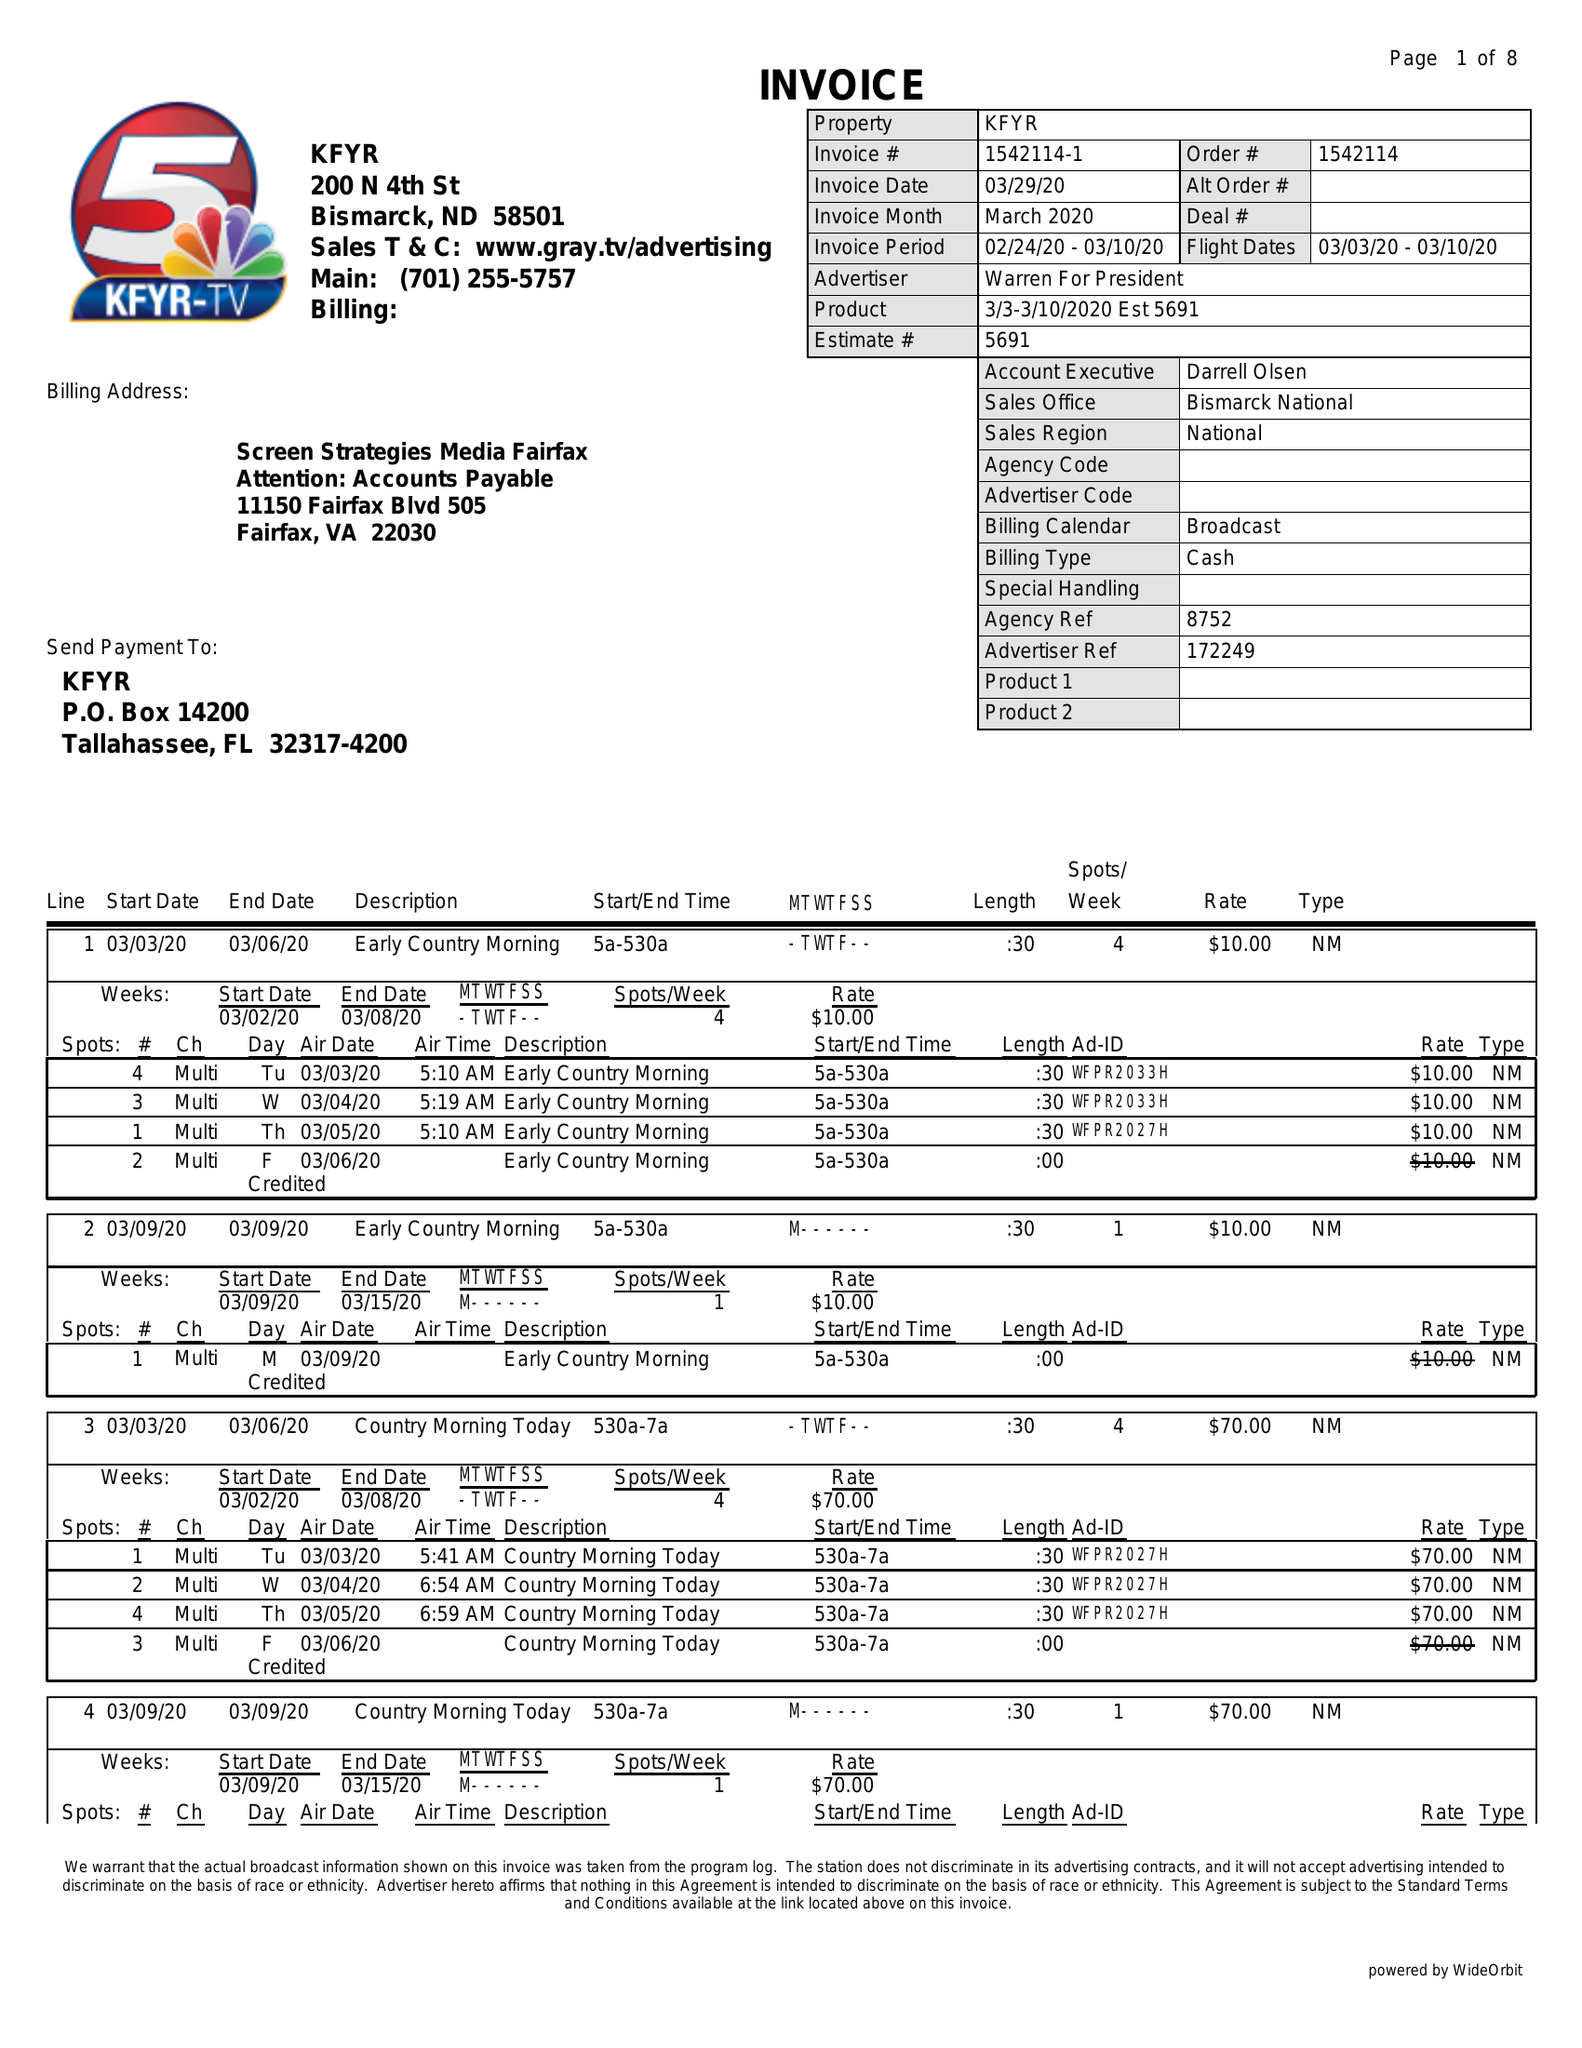What is the value for the flight_from?
Answer the question using a single word or phrase. 03/03/20 